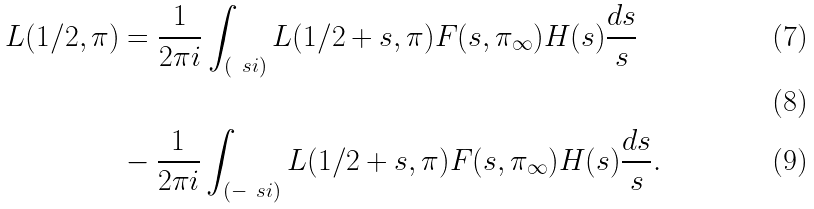Convert formula to latex. <formula><loc_0><loc_0><loc_500><loc_500>L ( 1 / 2 , \pi ) & = \frac { 1 } { 2 \pi i } \int _ { ( \ s i ) } L ( 1 / 2 + s , \pi ) F ( s , \pi _ { \infty } ) H ( s ) \frac { d s } { s } \\ \\ & - \frac { 1 } { 2 \pi i } \int _ { ( - \ s i ) } L ( 1 / 2 + s , \pi ) F ( s , \pi _ { \infty } ) H ( s ) \frac { d s } { s } .</formula> 